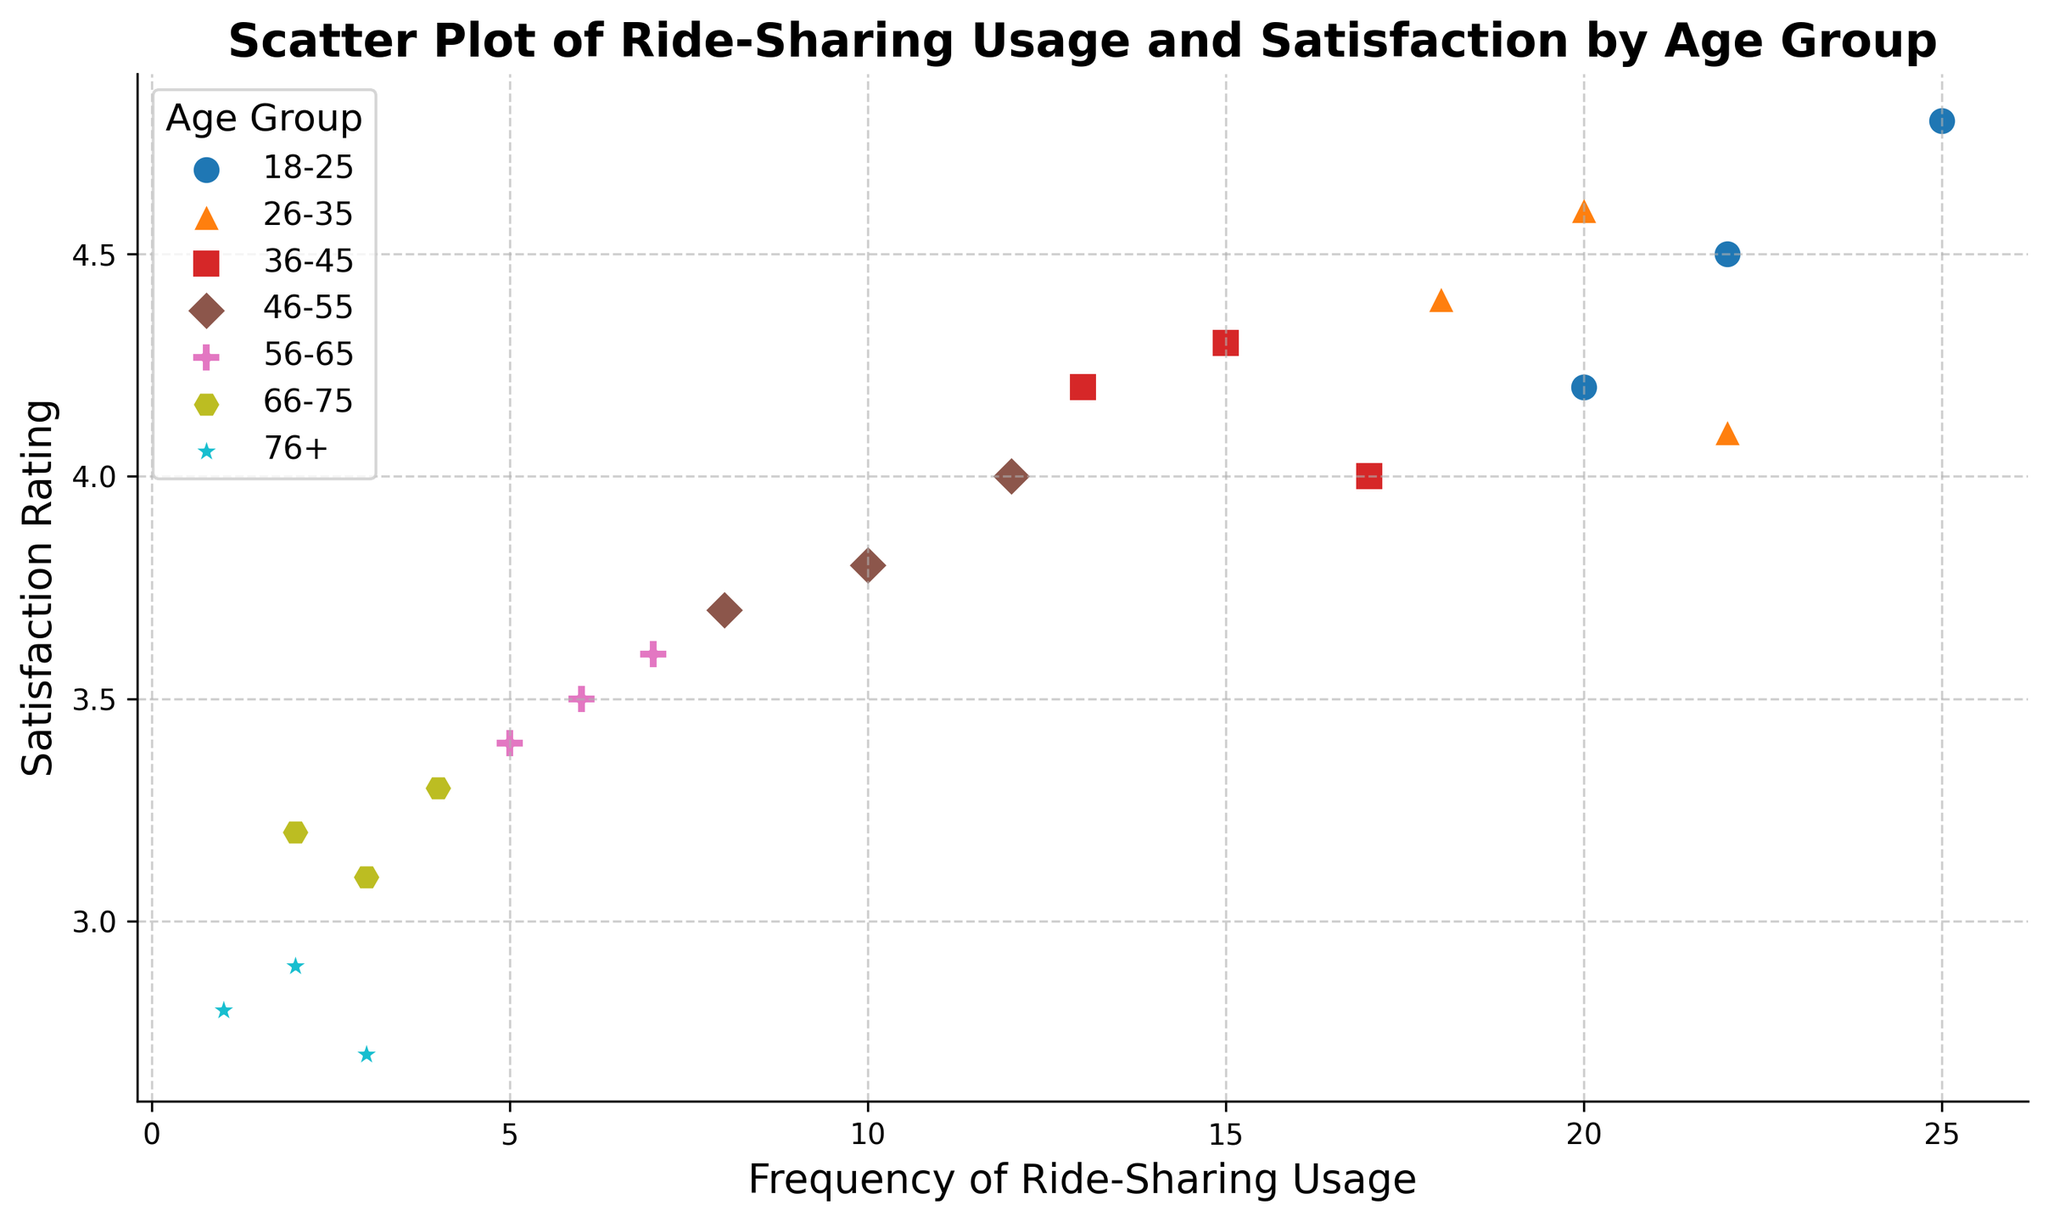What's the average satisfaction rating for the 56-65 age group? To find the average satisfaction rating, sum the ratings for the 56-65 age group and divide by the number of data points: (3.5 + 3.6 + 3.4) / 3 = 10.5 / 3 = 3.5
Answer: 3.5 Which age group has the highest frequency of ride-sharing usage? By examining the scatter plot, the 18-25 age group has the highest frequency points compared to other groups
Answer: 18-25 How do satisfaction ratings change with increasing age groups? Satisfaction ratings generally decrease as the age group increases. Younger age groups (e.g., 18-25) have higher satisfaction ratings, whereas older age groups (e.g., 76+) show lower ratings
Answer: Ratings generally decrease with age Compare the satisfaction rating of the 26-35 age group to the 46-55 age group. Look at the scatter plot points for both age groups. The 26-35 age group has ratings around 4.1 to 4.6, while the 46-55 age group has ratings around 3.7 to 4.0. Hence, the 26-35 age group has higher satisfaction on average compared to 46-55
Answer: 26-35 has higher ratings Which age group has the widest range of satisfaction ratings? By observing the spread of the satisfaction ratings in the scatter plot, the 26-35 and 18-25 age groups have wider ranges. However, the 18-25 age group has ratings spread from 4.2 to 4.8, showing the widest range
Answer: 18-25 What's the average frequency of ride-sharing usage for the 76+ age group? To calculate the average frequency for the 76+ age group, sum the frequencies and divide by the number of data points: (1 + 2 + 3) / 3 = 6 / 3 = 2
Answer: 2 Which age group has the lowest range of satisfaction ratings? By inspecting the scatter plot, the 76+ age group has ratings clustered around 2.7 to 2.9, indicating the smallest range
Answer: 76+ What is the general trend of ride-sharing frequency as age increases? Observing the scatter plot, the frequency of ride-sharing usage generally decreases as the age group increases
Answer: Frequency decreases with age 